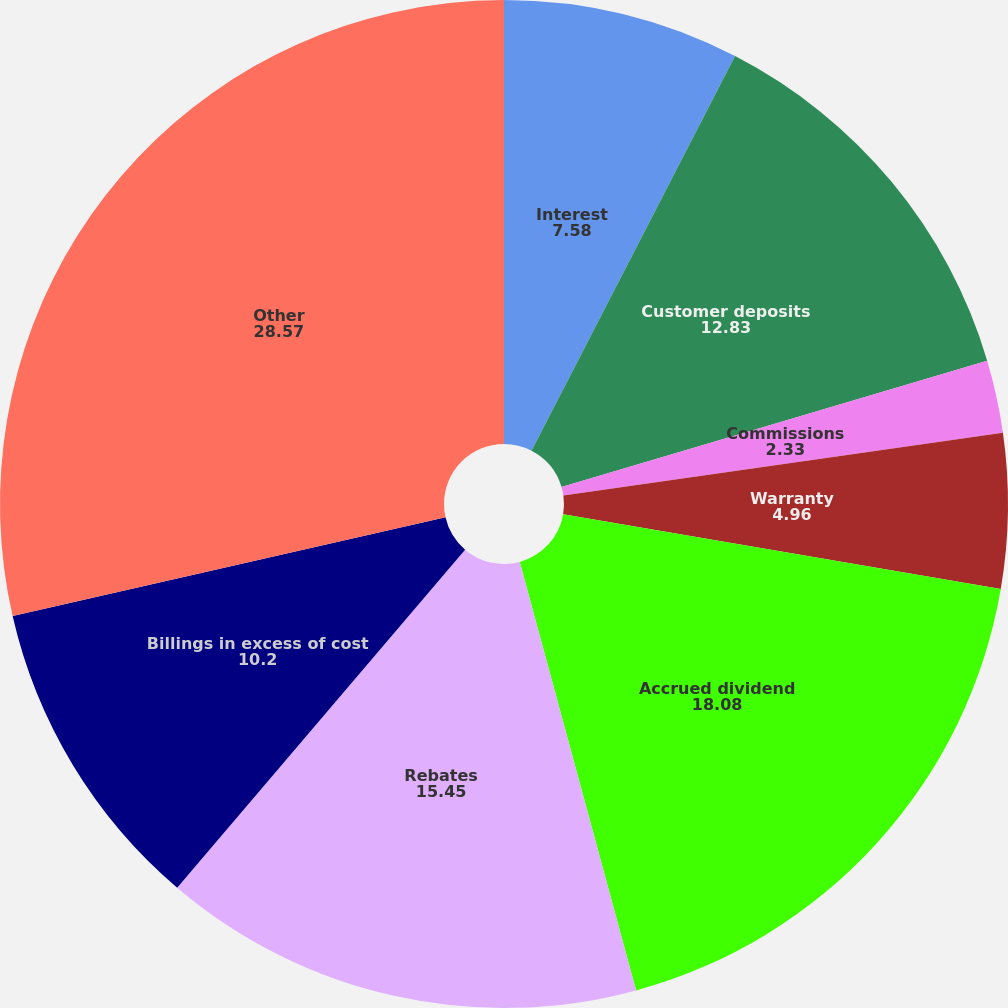Convert chart. <chart><loc_0><loc_0><loc_500><loc_500><pie_chart><fcel>Interest<fcel>Customer deposits<fcel>Commissions<fcel>Warranty<fcel>Accrued dividend<fcel>Rebates<fcel>Billings in excess of cost<fcel>Other<nl><fcel>7.58%<fcel>12.83%<fcel>2.33%<fcel>4.96%<fcel>18.08%<fcel>15.45%<fcel>10.2%<fcel>28.57%<nl></chart> 